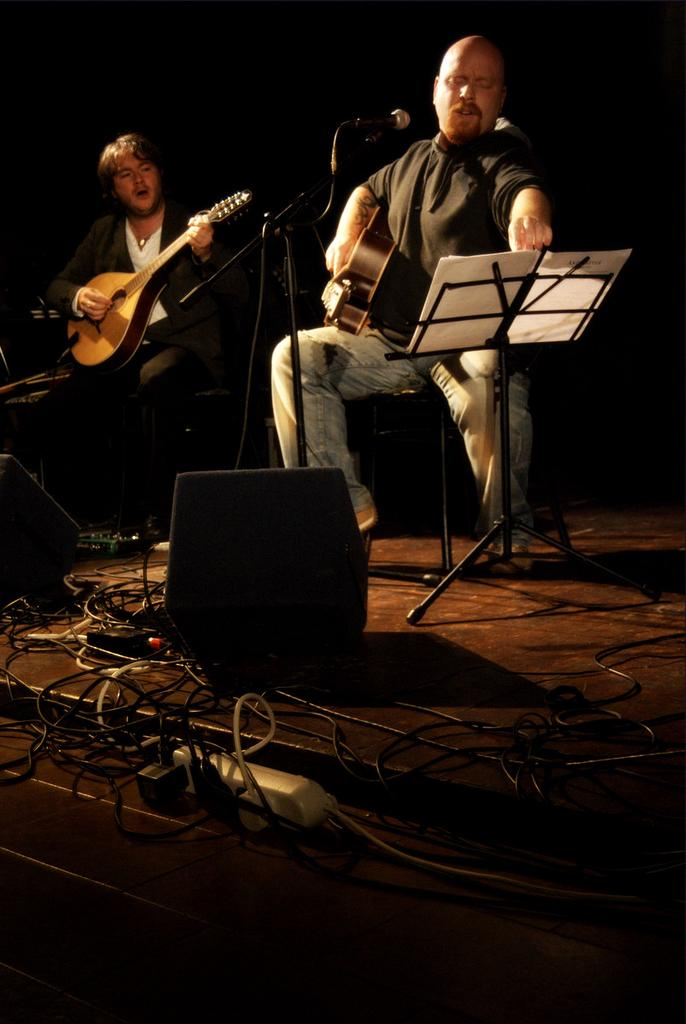How many people are in the image? There are two men in the image. What are the men doing in the image? The men are sitting and playing guitars. Where are the men located in the image? The men are on a stage. What type of shade is being used by the men to protect themselves from the sun in the image? There is no shade present in the image, as the men are indoors on a stage. What card game are the men playing while they are on the stage? The men are not playing a card game; they are playing guitars. 